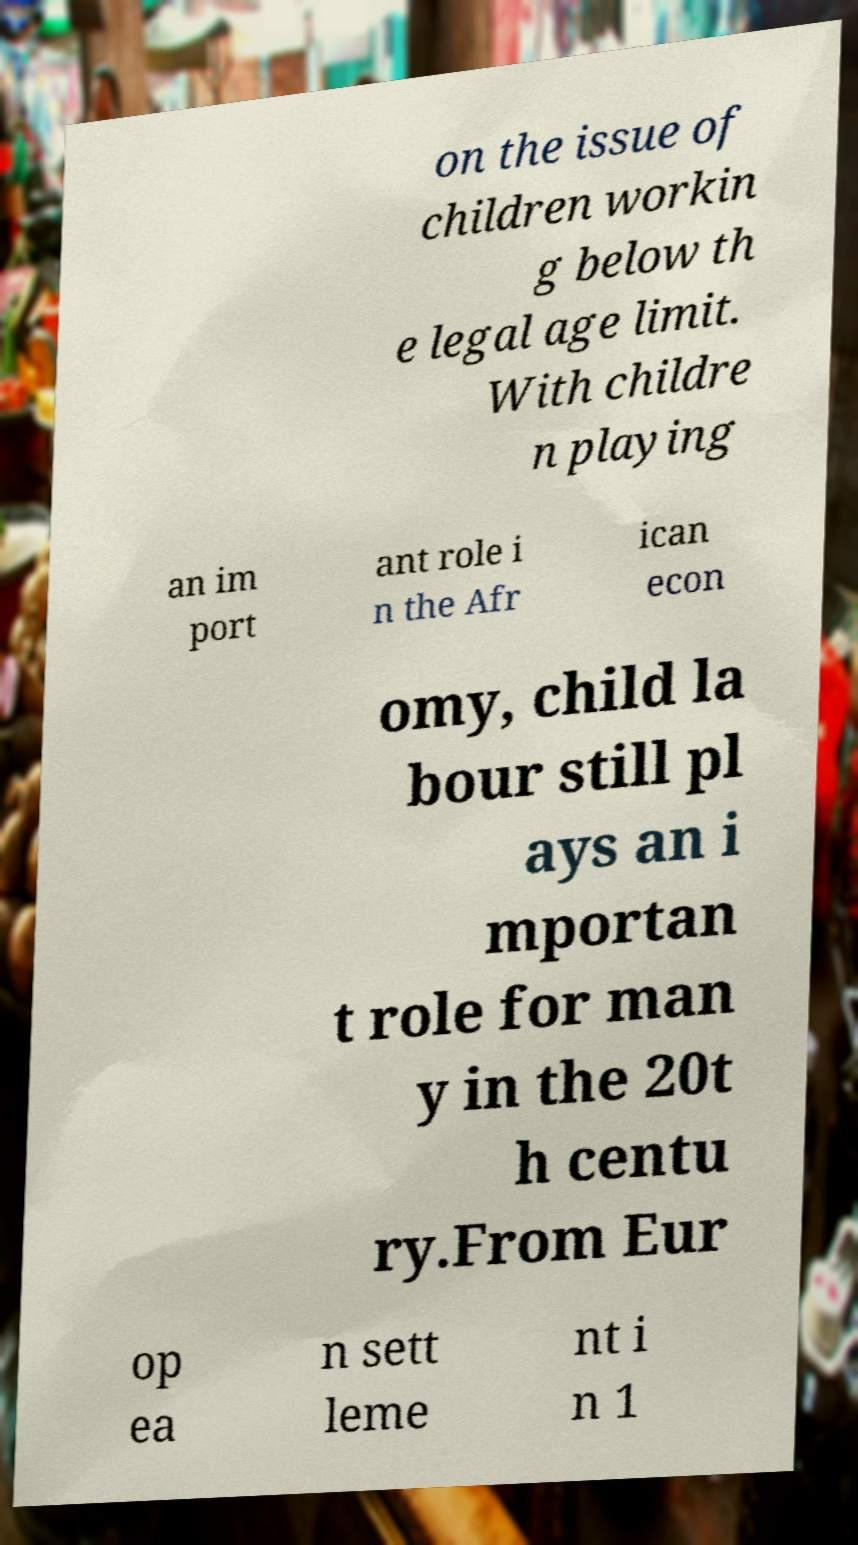There's text embedded in this image that I need extracted. Can you transcribe it verbatim? on the issue of children workin g below th e legal age limit. With childre n playing an im port ant role i n the Afr ican econ omy, child la bour still pl ays an i mportan t role for man y in the 20t h centu ry.From Eur op ea n sett leme nt i n 1 